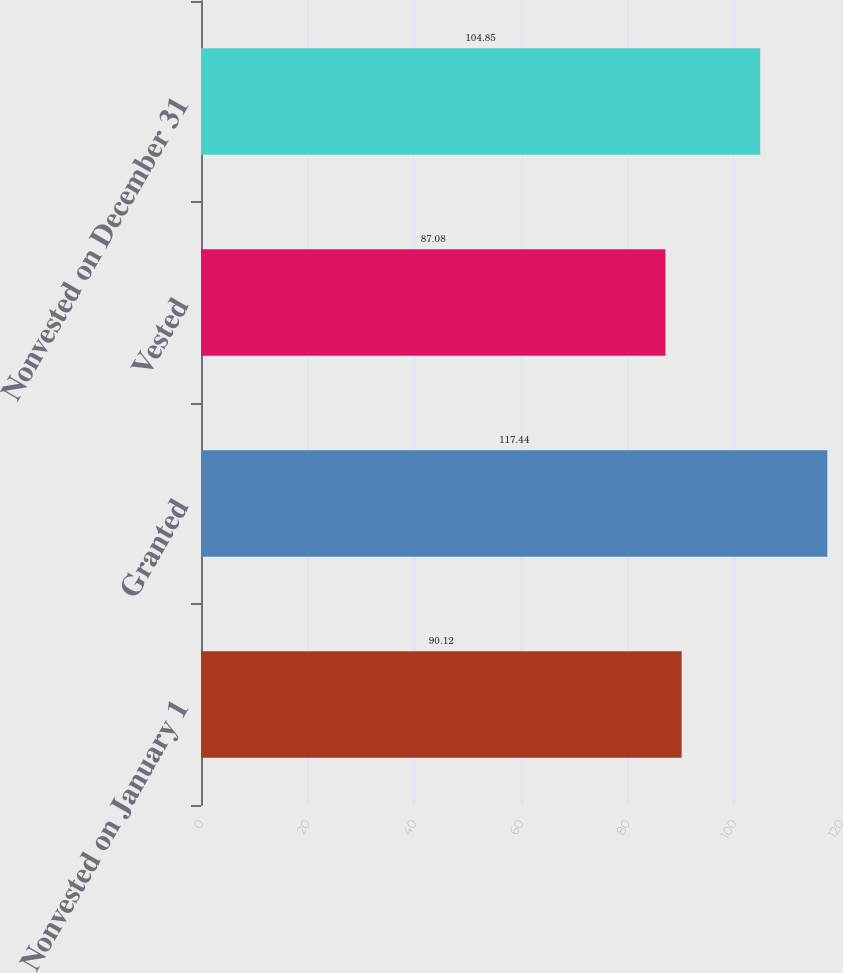Convert chart to OTSL. <chart><loc_0><loc_0><loc_500><loc_500><bar_chart><fcel>Nonvested on January 1<fcel>Granted<fcel>Vested<fcel>Nonvested on December 31<nl><fcel>90.12<fcel>117.44<fcel>87.08<fcel>104.85<nl></chart> 